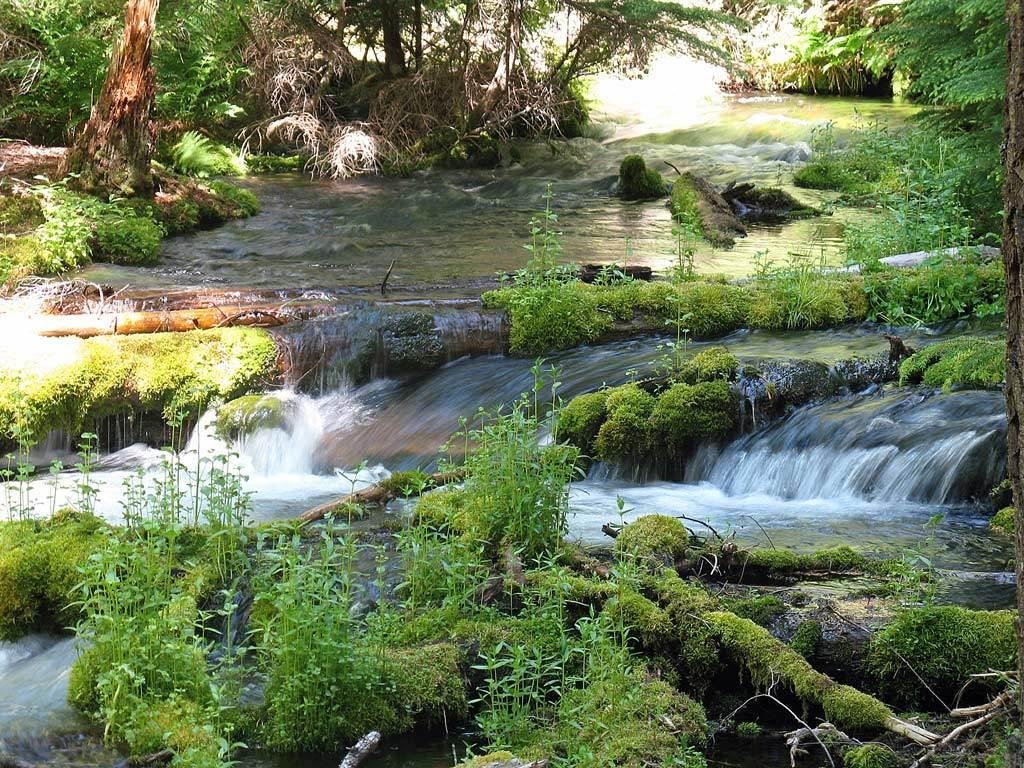What is the primary subject of the image? The primary subject of the image is the many plants. Can you describe the flow of water in the image? Yes, there is a flow of water in the image. What type of nail is being used to perform magic in the image? There is no nail or magic present in the image; it features many plants and a flow of water. 